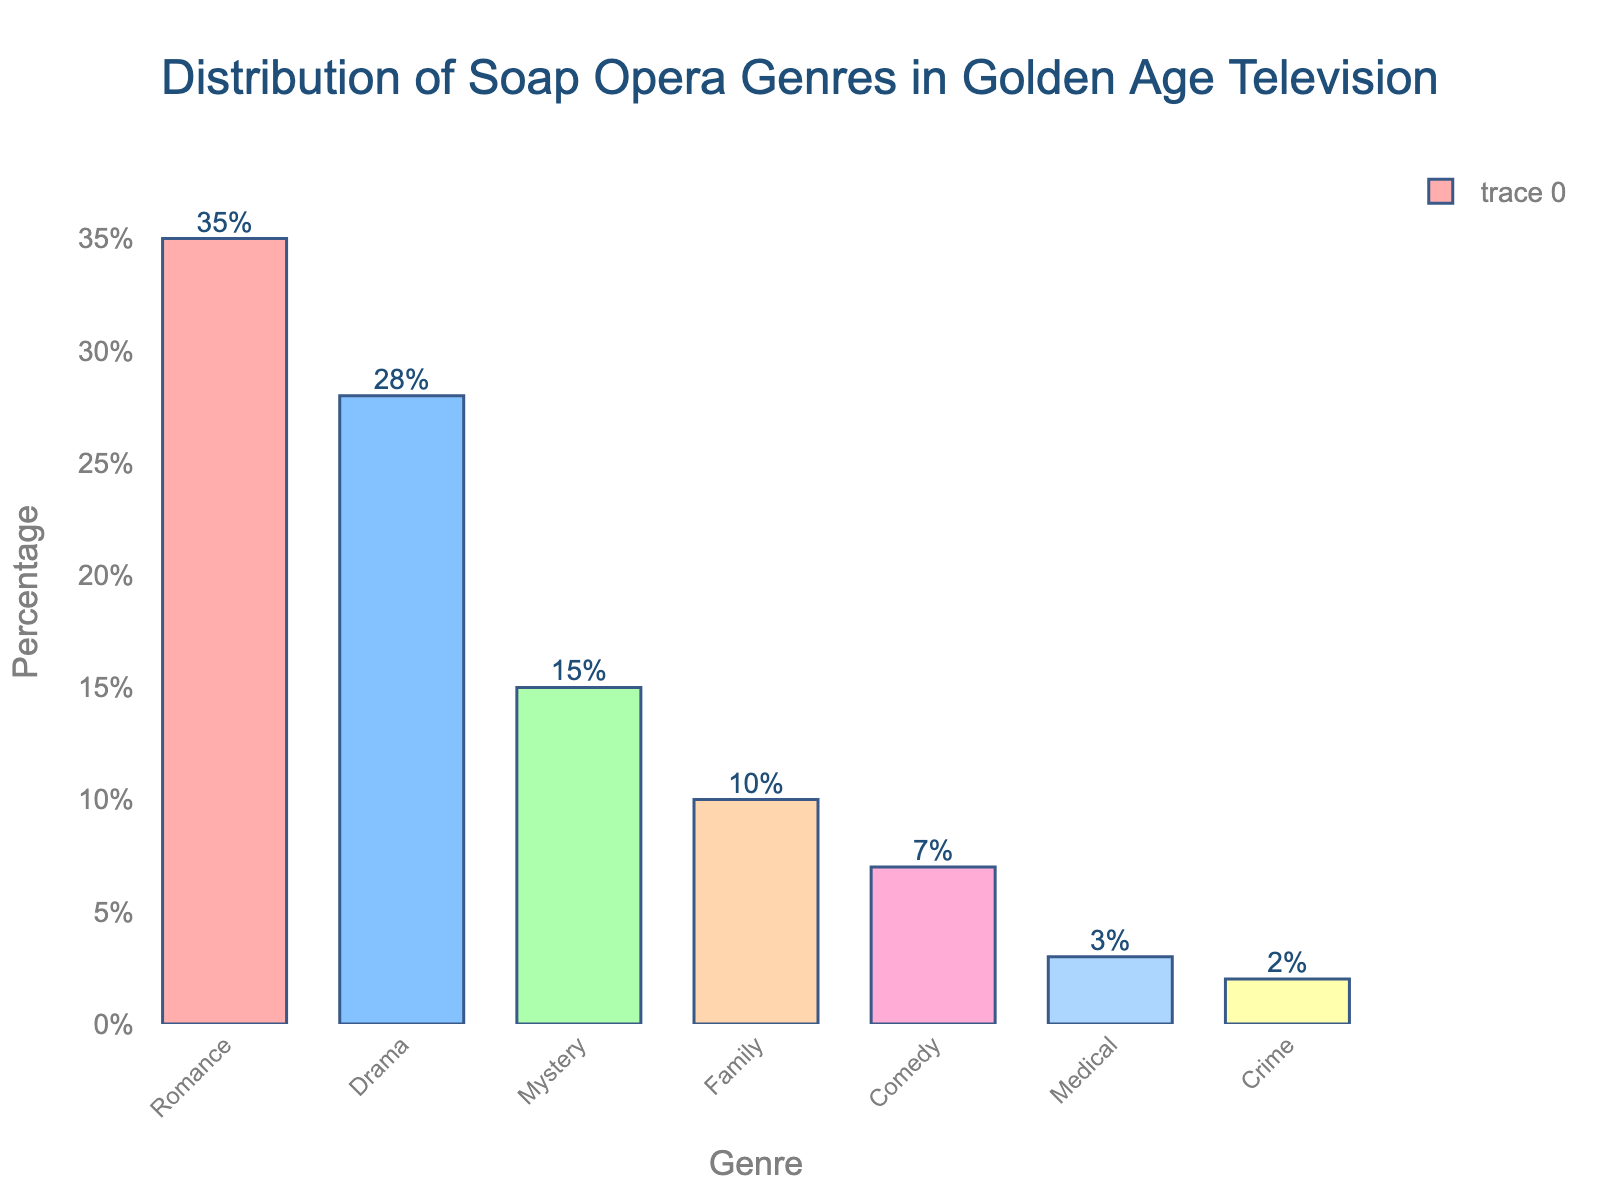What genre has the highest percentage? Locate the tallest bar in the bar chart. The tallest bar represents the genre with the highest percentage.
Answer: Romance Which two genres combined make up over half of the distribution? Sum the percentages of the top genres until the total exceeds 50%. Romance (35%) and Drama (28%) together are 63%.
Answer: Romance and Drama How much greater is the percentage of Romance compared to Comedy? Subtract the percentage of Comedy from the percentage of Romance. Romance is 35% and Comedy is 7%. 35% - 7% equals 28%.
Answer: 28% Which genre has the lowest percentage? Locate the shortest bar in the bar chart. The shortest bar represents the genre with the lowest percentage.
Answer: Crime What is the average percentage of the Mystery and Family genres? First, sum the percentages of Mystery and Family. Mystery is 15% and Family is 10%, totaling 25%. Then divide by 2. 25% / 2 equals 12.5%.
Answer: 12.5% Arrange the genres in descending order based on their percentages. Observe the lengths of the bars or the labels to determine the order from the highest to the lowest percentage.
Answer: Romance, Drama, Mystery, Family, Comedy, Medical, Crime What is the cumulative percentage of the bottom three genres? Add the percentages of the bottom three genres. Medical is 3%, Comedy is 7%, and Crime is 2%. 3% + 7% + 2% equals 12%.
Answer: 12% Which genre is between Mystery and Comedy in terms of percentage? Identify the percentages for Mystery (15%) and Comedy (7%), and find the genre with the percentage between these values. Family, with 10%, is in between.
Answer: Family By how much does the percentage of Drama exceed that of Medical? Subtract the percentage of Medical from that of Drama. Drama is 28% and Medical is 3%. 28% - 3% equals 25%.
Answer: 25% What visual characteristic helps to quickly identify the genre with the highest percentage? The tallest bar in the bar chart visually indicates the genre with the highest percentage. This height difference makes it quickly identifiable.
Answer: Tallest bar 